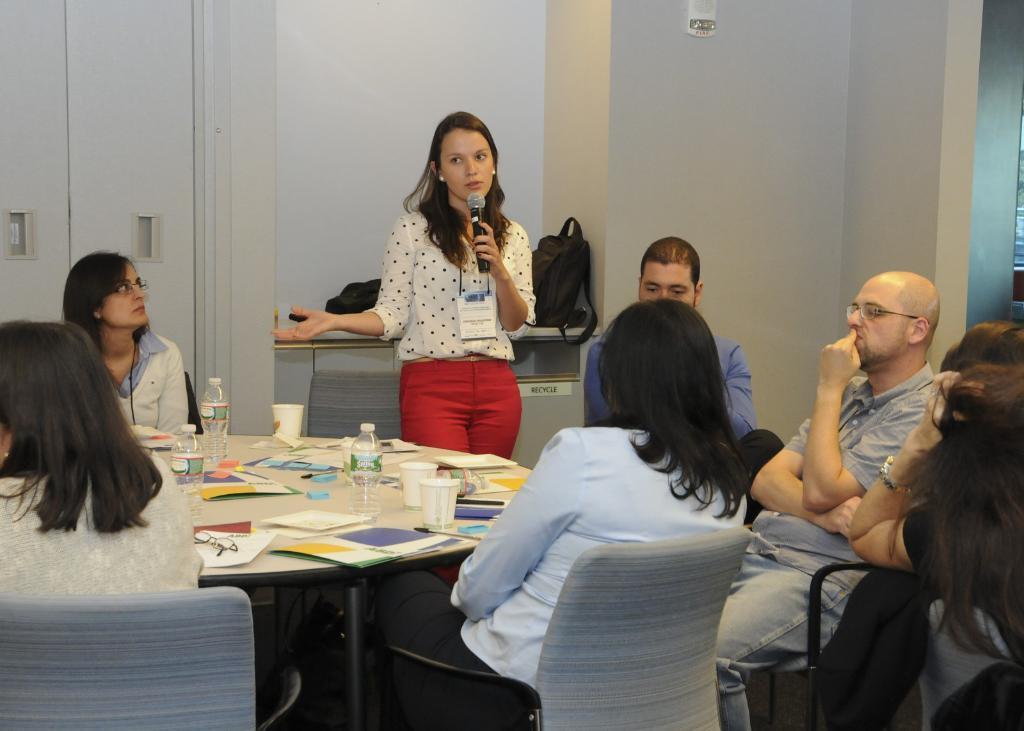Can you describe this image briefly? In this picture we can see a group of people and they are sitting on chairs, one woman is standing and she is holding a mic, here we can see a table, on this table we can see bottles, cups, papers and some objects and in the background we can see a wall, bags. 